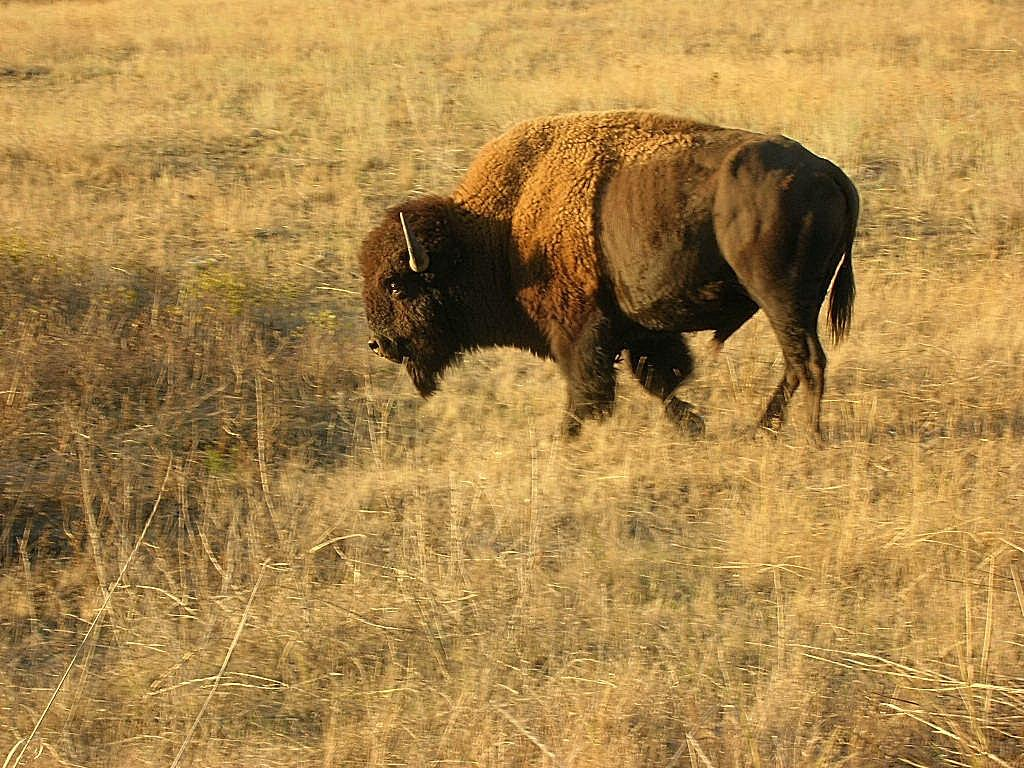What type of vegetation is present in the image? There is grass in the image. What can be seen on the ground in the image? There is an animal on the ground in the image. What type of trade is happening between the grass and the animal in the image? There is no trade happening between the grass and the animal in the image; they are simply coexisting in the same environment. 